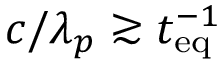Convert formula to latex. <formula><loc_0><loc_0><loc_500><loc_500>c / \lambda _ { p } \gtrsim t _ { e q } ^ { - 1 }</formula> 